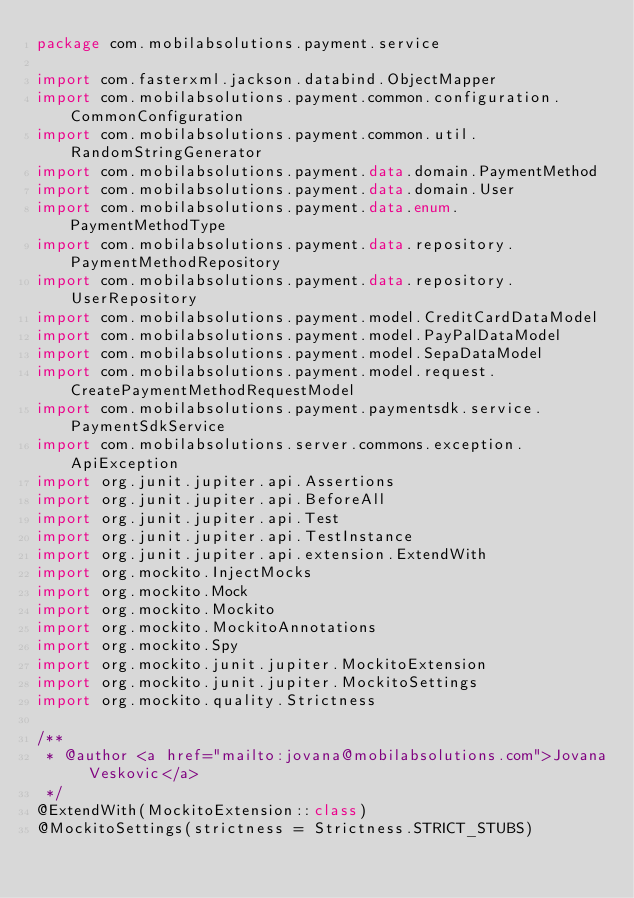<code> <loc_0><loc_0><loc_500><loc_500><_Kotlin_>package com.mobilabsolutions.payment.service

import com.fasterxml.jackson.databind.ObjectMapper
import com.mobilabsolutions.payment.common.configuration.CommonConfiguration
import com.mobilabsolutions.payment.common.util.RandomStringGenerator
import com.mobilabsolutions.payment.data.domain.PaymentMethod
import com.mobilabsolutions.payment.data.domain.User
import com.mobilabsolutions.payment.data.enum.PaymentMethodType
import com.mobilabsolutions.payment.data.repository.PaymentMethodRepository
import com.mobilabsolutions.payment.data.repository.UserRepository
import com.mobilabsolutions.payment.model.CreditCardDataModel
import com.mobilabsolutions.payment.model.PayPalDataModel
import com.mobilabsolutions.payment.model.SepaDataModel
import com.mobilabsolutions.payment.model.request.CreatePaymentMethodRequestModel
import com.mobilabsolutions.payment.paymentsdk.service.PaymentSdkService
import com.mobilabsolutions.server.commons.exception.ApiException
import org.junit.jupiter.api.Assertions
import org.junit.jupiter.api.BeforeAll
import org.junit.jupiter.api.Test
import org.junit.jupiter.api.TestInstance
import org.junit.jupiter.api.extension.ExtendWith
import org.mockito.InjectMocks
import org.mockito.Mock
import org.mockito.Mockito
import org.mockito.MockitoAnnotations
import org.mockito.Spy
import org.mockito.junit.jupiter.MockitoExtension
import org.mockito.junit.jupiter.MockitoSettings
import org.mockito.quality.Strictness

/**
 * @author <a href="mailto:jovana@mobilabsolutions.com">Jovana Veskovic</a>
 */
@ExtendWith(MockitoExtension::class)
@MockitoSettings(strictness = Strictness.STRICT_STUBS)</code> 